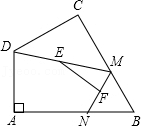Could you explain why EF is calculated as half of DN in the diagram? Certainly! In the diagram, EF is a segment that connects the midpoints of segments DM and MN. According to the midpoint theorem in geometry, the segment connecting the midpoints of two sides of a triangle is parallel to the third side and is half as long as this third side. Hence, since EF connects the midpoints of DM and MN, its length is half of DN, which is the base of triangle DNB if we consider N coinciding with B at its maximum stretch. 